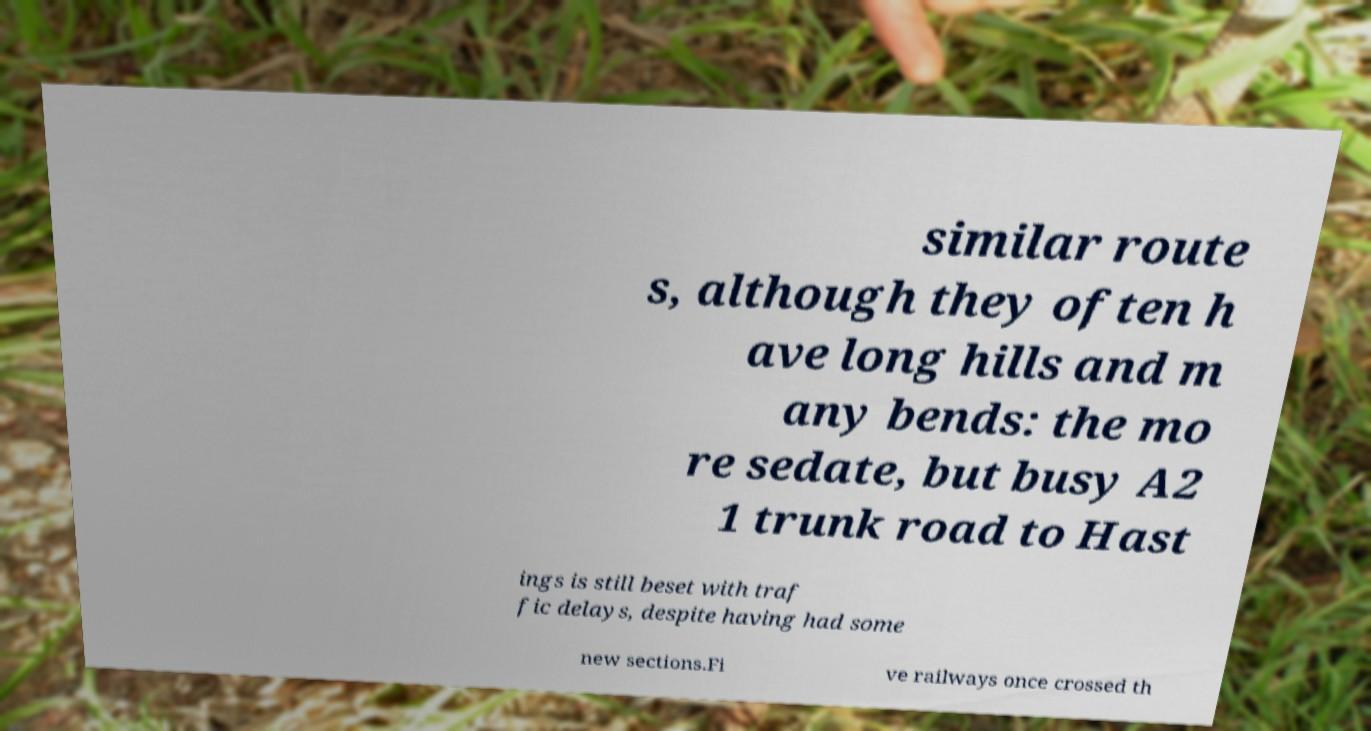Can you read and provide the text displayed in the image?This photo seems to have some interesting text. Can you extract and type it out for me? similar route s, although they often h ave long hills and m any bends: the mo re sedate, but busy A2 1 trunk road to Hast ings is still beset with traf fic delays, despite having had some new sections.Fi ve railways once crossed th 